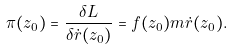<formula> <loc_0><loc_0><loc_500><loc_500>\pi ( z _ { 0 } ) = \frac { \delta L } { \delta \dot { r } ( z _ { 0 } ) } = f ( z _ { 0 } ) m \dot { r } ( z _ { 0 } ) .</formula> 